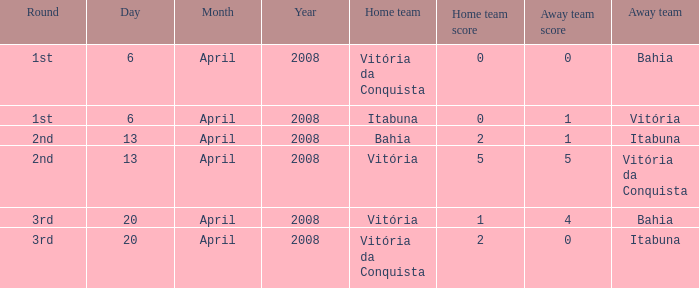Which team played as the home side on april 13, 2008 when itabuna was the opposing team? Bahia. Help me parse the entirety of this table. {'header': ['Round', 'Day', 'Month', 'Year', 'Home team', 'Home team score', 'Away team score', 'Away team'], 'rows': [['1st', '6', 'April', '2008', 'Vitória da Conquista', '0', '0', 'Bahia'], ['1st', '6', 'April', '2008', 'Itabuna', '0', '1', 'Vitória'], ['2nd', '13', 'April', '2008', 'Bahia', '2', '1', 'Itabuna'], ['2nd', '13', 'April', '2008', 'Vitória', '5', '5', 'Vitória da Conquista'], ['3rd', '20', 'April', '2008', 'Vitória', '1', '4', 'Bahia'], ['3rd', '20', 'April', '2008', 'Vitória da Conquista', '2', '0', 'Itabuna']]} 